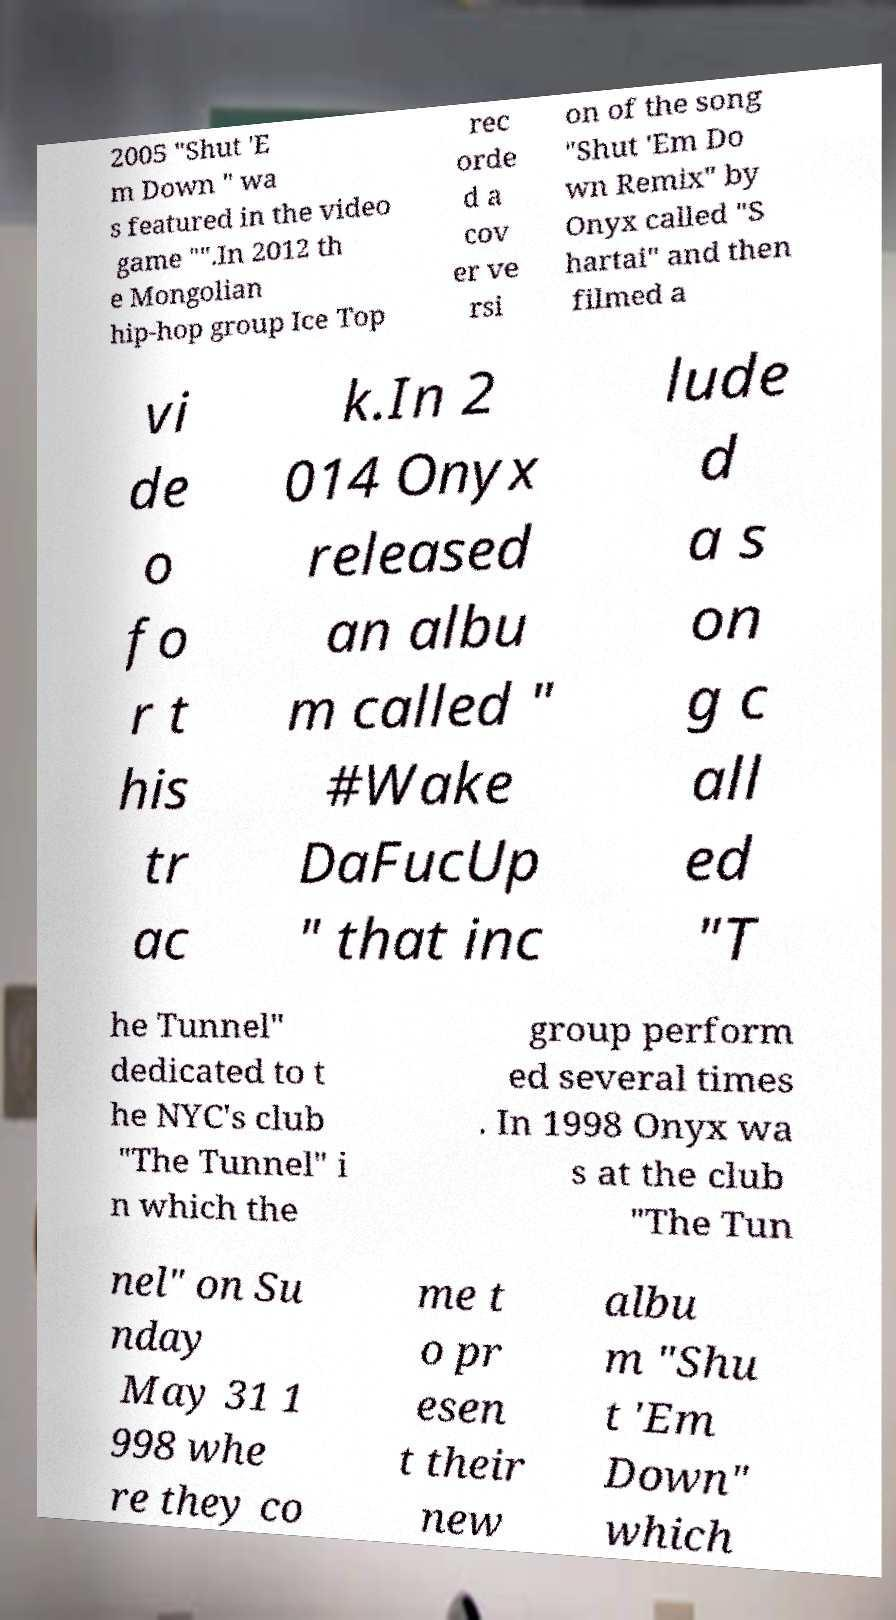Please identify and transcribe the text found in this image. 2005 "Shut 'E m Down " wa s featured in the video game "".In 2012 th e Mongolian hip-hop group Ice Top rec orde d a cov er ve rsi on of the song "Shut 'Em Do wn Remix" by Onyx called "S hartai" and then filmed a vi de o fo r t his tr ac k.In 2 014 Onyx released an albu m called " #Wake DaFucUp " that inc lude d a s on g c all ed "T he Tunnel" dedicated to t he NYC's club "The Tunnel" i n which the group perform ed several times . In 1998 Onyx wa s at the club "The Tun nel" on Su nday May 31 1 998 whe re they co me t o pr esen t their new albu m "Shu t 'Em Down" which 